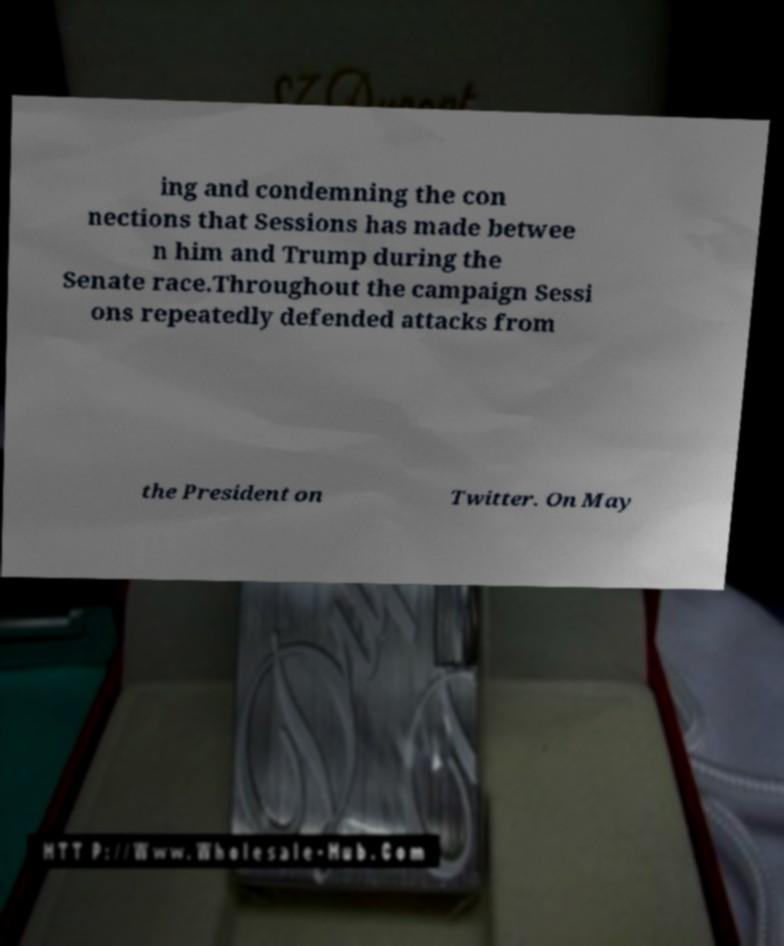Could you assist in decoding the text presented in this image and type it out clearly? ing and condemning the con nections that Sessions has made betwee n him and Trump during the Senate race.Throughout the campaign Sessi ons repeatedly defended attacks from the President on Twitter. On May 